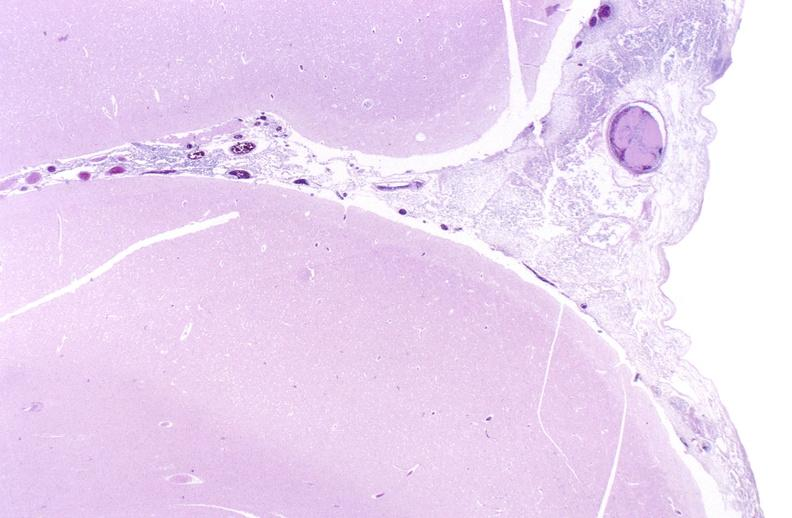what does this image show?
Answer the question using a single word or phrase. Bacterial meningitis 